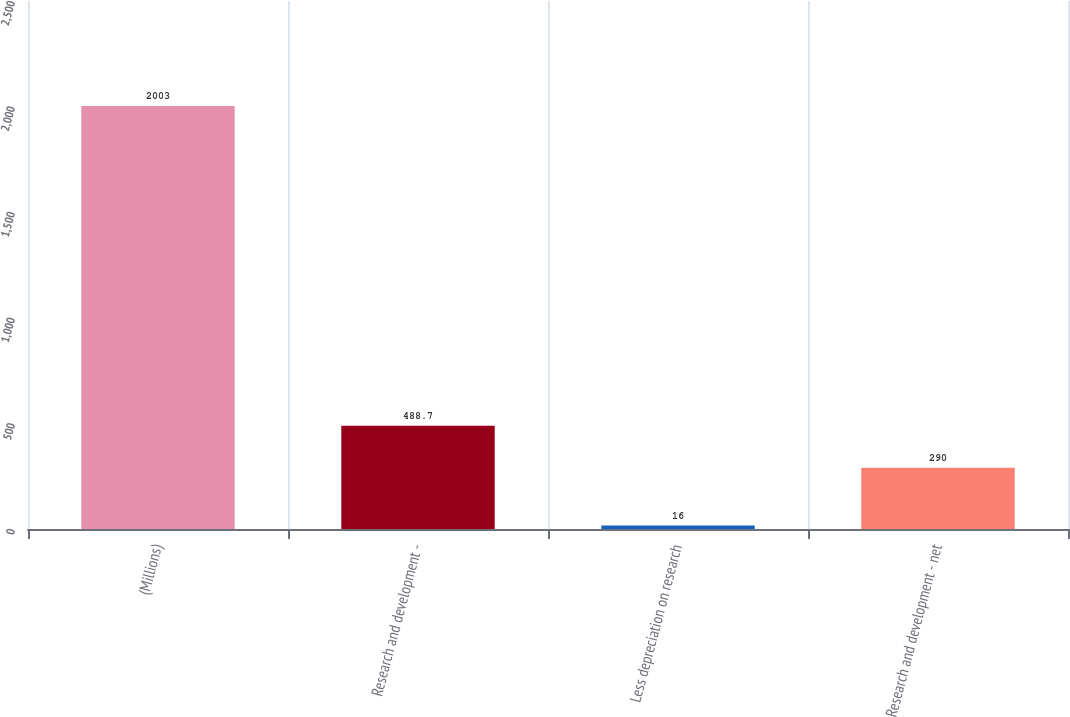<chart> <loc_0><loc_0><loc_500><loc_500><bar_chart><fcel>(Millions)<fcel>Research and development -<fcel>Less depreciation on research<fcel>Research and development - net<nl><fcel>2003<fcel>488.7<fcel>16<fcel>290<nl></chart> 